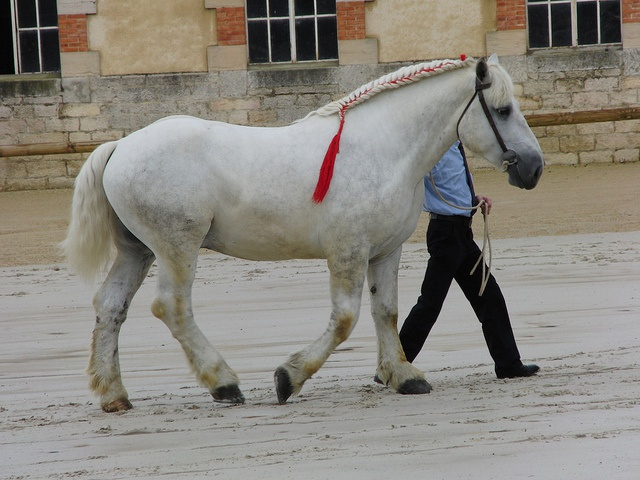Describe the objects in this image and their specific colors. I can see horse in black, darkgray, and gray tones and people in black and gray tones in this image. 